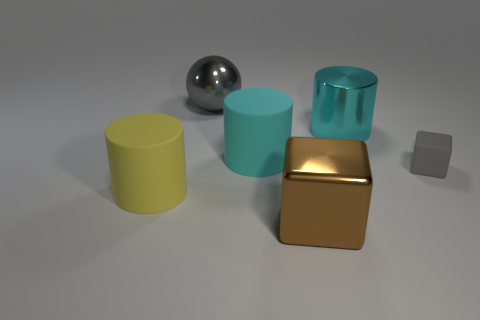Are there any objects with reflective surfaces? Yes, the spherical object in the back appears to have a highly reflective surface, mirroring the environment around it. 